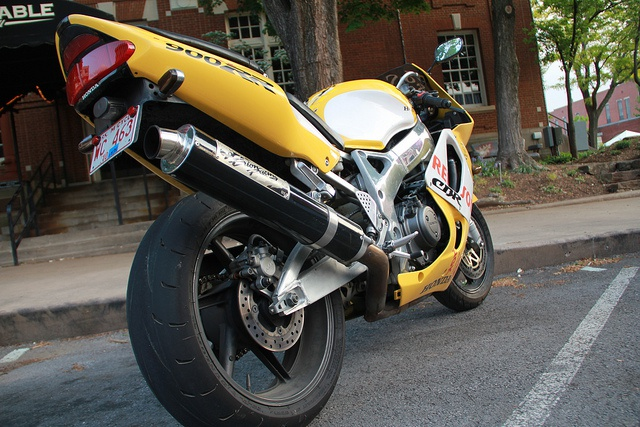Describe the objects in this image and their specific colors. I can see a motorcycle in black, gray, white, and darkgray tones in this image. 